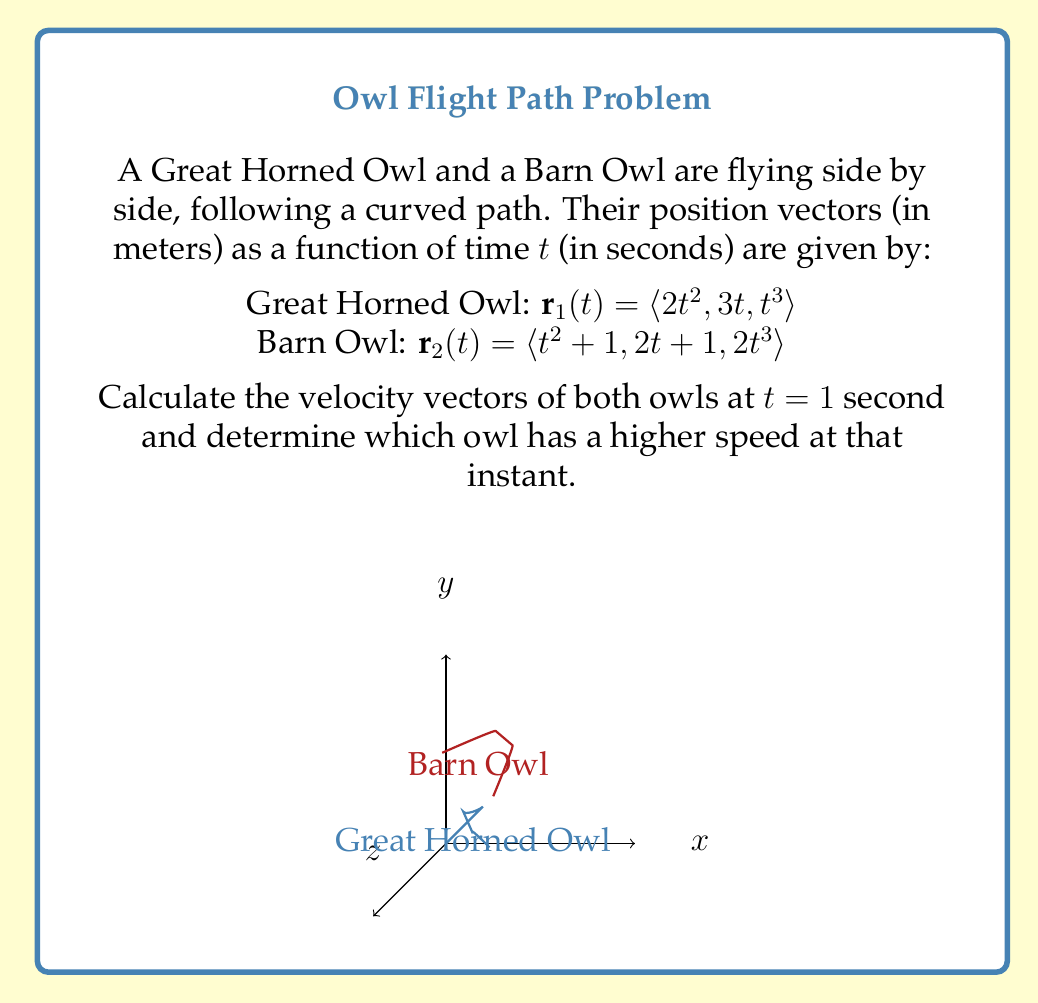Teach me how to tackle this problem. To solve this problem, we need to follow these steps:

1) First, let's find the velocity vectors for both owls by differentiating their position vectors with respect to time:

   Great Horned Owl:
   $$\mathbf{v}_1(t) = \frac{d}{dt}\mathbf{r}_1(t) = \langle 4t, 3, 3t^2 \rangle$$

   Barn Owl:
   $$\mathbf{v}_2(t) = \frac{d}{dt}\mathbf{r}_2(t) = \langle 2t, 2, 6t^2 \rangle$$

2) Now, let's calculate the velocity vectors at t = 1 second:

   Great Horned Owl:
   $$\mathbf{v}_1(1) = \langle 4(1), 3, 3(1)^2 \rangle = \langle 4, 3, 3 \rangle$$

   Barn Owl:
   $$\mathbf{v}_2(1) = \langle 2(1), 2, 6(1)^2 \rangle = \langle 2, 2, 6 \rangle$$

3) To determine which owl has a higher speed, we need to calculate the magnitude of each velocity vector:

   Speed of Great Horned Owl:
   $$|\mathbf{v}_1(1)| = \sqrt{4^2 + 3^2 + 3^2} = \sqrt{16 + 9 + 9} = \sqrt{34} \approx 5.83 \text{ m/s}$$

   Speed of Barn Owl:
   $$|\mathbf{v}_2(1)| = \sqrt{2^2 + 2^2 + 6^2} = \sqrt{4 + 4 + 36} = \sqrt{44} \approx 6.63 \text{ m/s}$$

4) Comparing the speeds, we can see that the Barn Owl has a higher speed at t = 1 second.
Answer: Great Horned Owl: $\langle 4, 3, 3 \rangle$ m/s; Barn Owl: $\langle 2, 2, 6 \rangle$ m/s; Barn Owl is faster. 